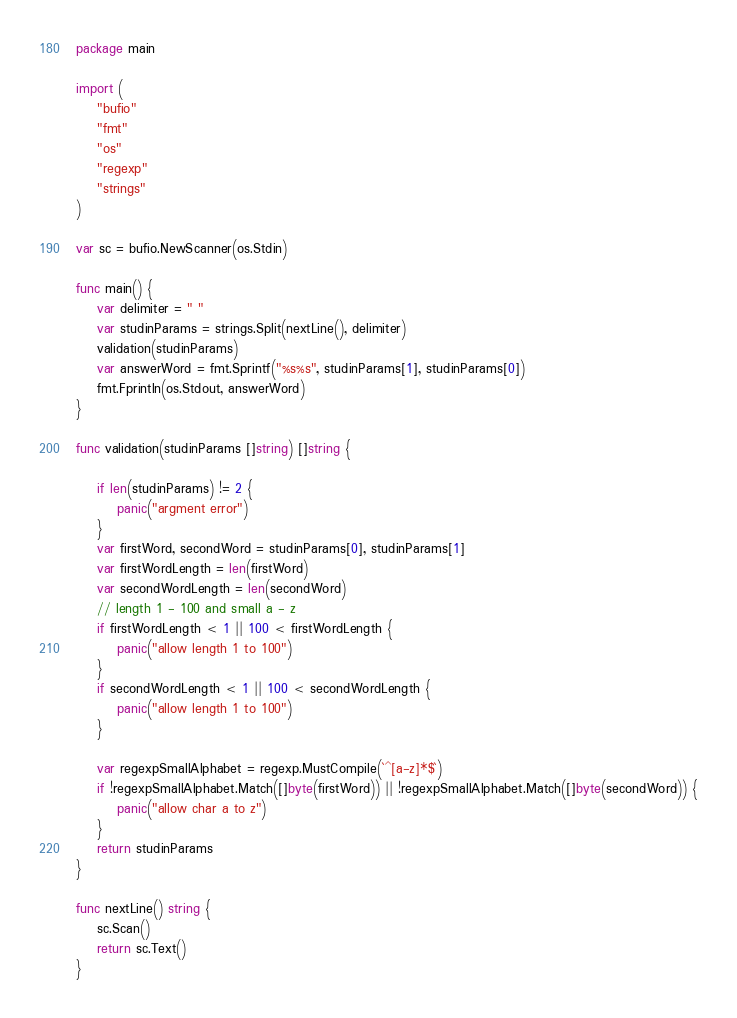<code> <loc_0><loc_0><loc_500><loc_500><_Go_>package main

import (
	"bufio"
	"fmt"
	"os"
	"regexp"
	"strings"
)

var sc = bufio.NewScanner(os.Stdin)

func main() {
	var delimiter = " "
	var studinParams = strings.Split(nextLine(), delimiter)
	validation(studinParams)
	var answerWord = fmt.Sprintf("%s%s", studinParams[1], studinParams[0])
	fmt.Fprintln(os.Stdout, answerWord)
}

func validation(studinParams []string) []string {

	if len(studinParams) != 2 {
		panic("argment error")
	}
	var firstWord, secondWord = studinParams[0], studinParams[1]
	var firstWordLength = len(firstWord)
	var secondWordLength = len(secondWord)
	// length 1 - 100 and small a - z
	if firstWordLength < 1 || 100 < firstWordLength {
		panic("allow length 1 to 100")
	}
	if secondWordLength < 1 || 100 < secondWordLength {
		panic("allow length 1 to 100")
	}

	var regexpSmallAlphabet = regexp.MustCompile(`^[a-z]*$`)
	if !regexpSmallAlphabet.Match([]byte(firstWord)) || !regexpSmallAlphabet.Match([]byte(secondWord)) {
		panic("allow char a to z")
	}
	return studinParams
}

func nextLine() string {
	sc.Scan()
	return sc.Text()
}
</code> 